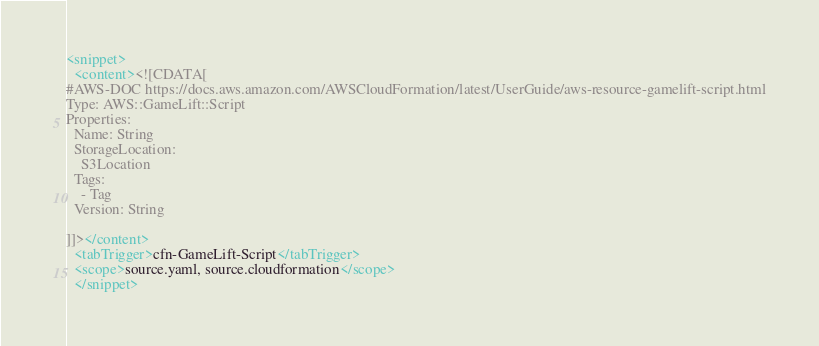<code> <loc_0><loc_0><loc_500><loc_500><_XML_><snippet>
  <content><![CDATA[
#AWS-DOC https://docs.aws.amazon.com/AWSCloudFormation/latest/UserGuide/aws-resource-gamelift-script.html
Type: AWS::GameLift::Script
Properties: 
  Name: String
  StorageLocation: 
    S3Location
  Tags: 
    - Tag
  Version: String

]]></content>
  <tabTrigger>cfn-GameLift-Script</tabTrigger>
  <scope>source.yaml, source.cloudformation</scope>
  </snippet></code> 